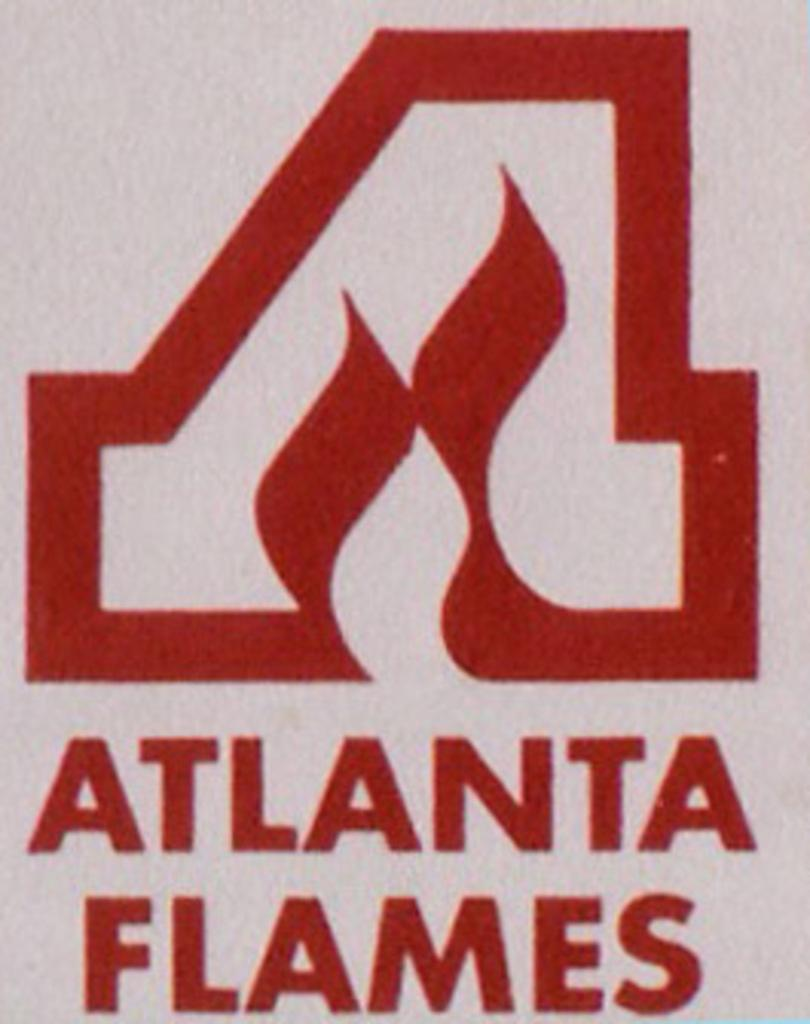<image>
Render a clear and concise summary of the photo. A white background has a red logo and the text "ATLANTA FLAMES." 